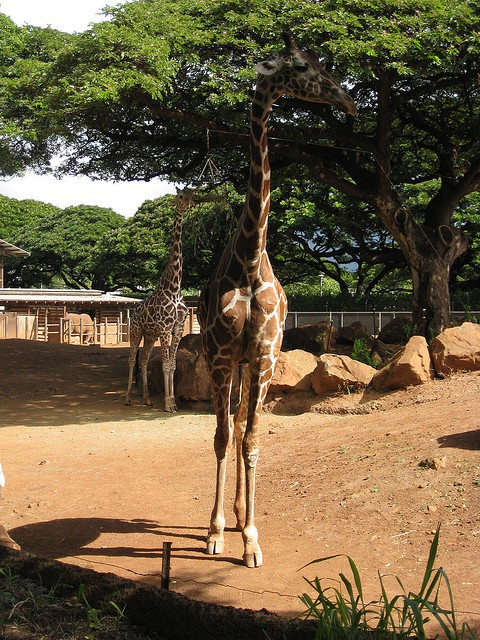Describe the objects in this image and their specific colors. I can see giraffe in white, black, maroon, and tan tones and giraffe in white, black, maroon, and gray tones in this image. 